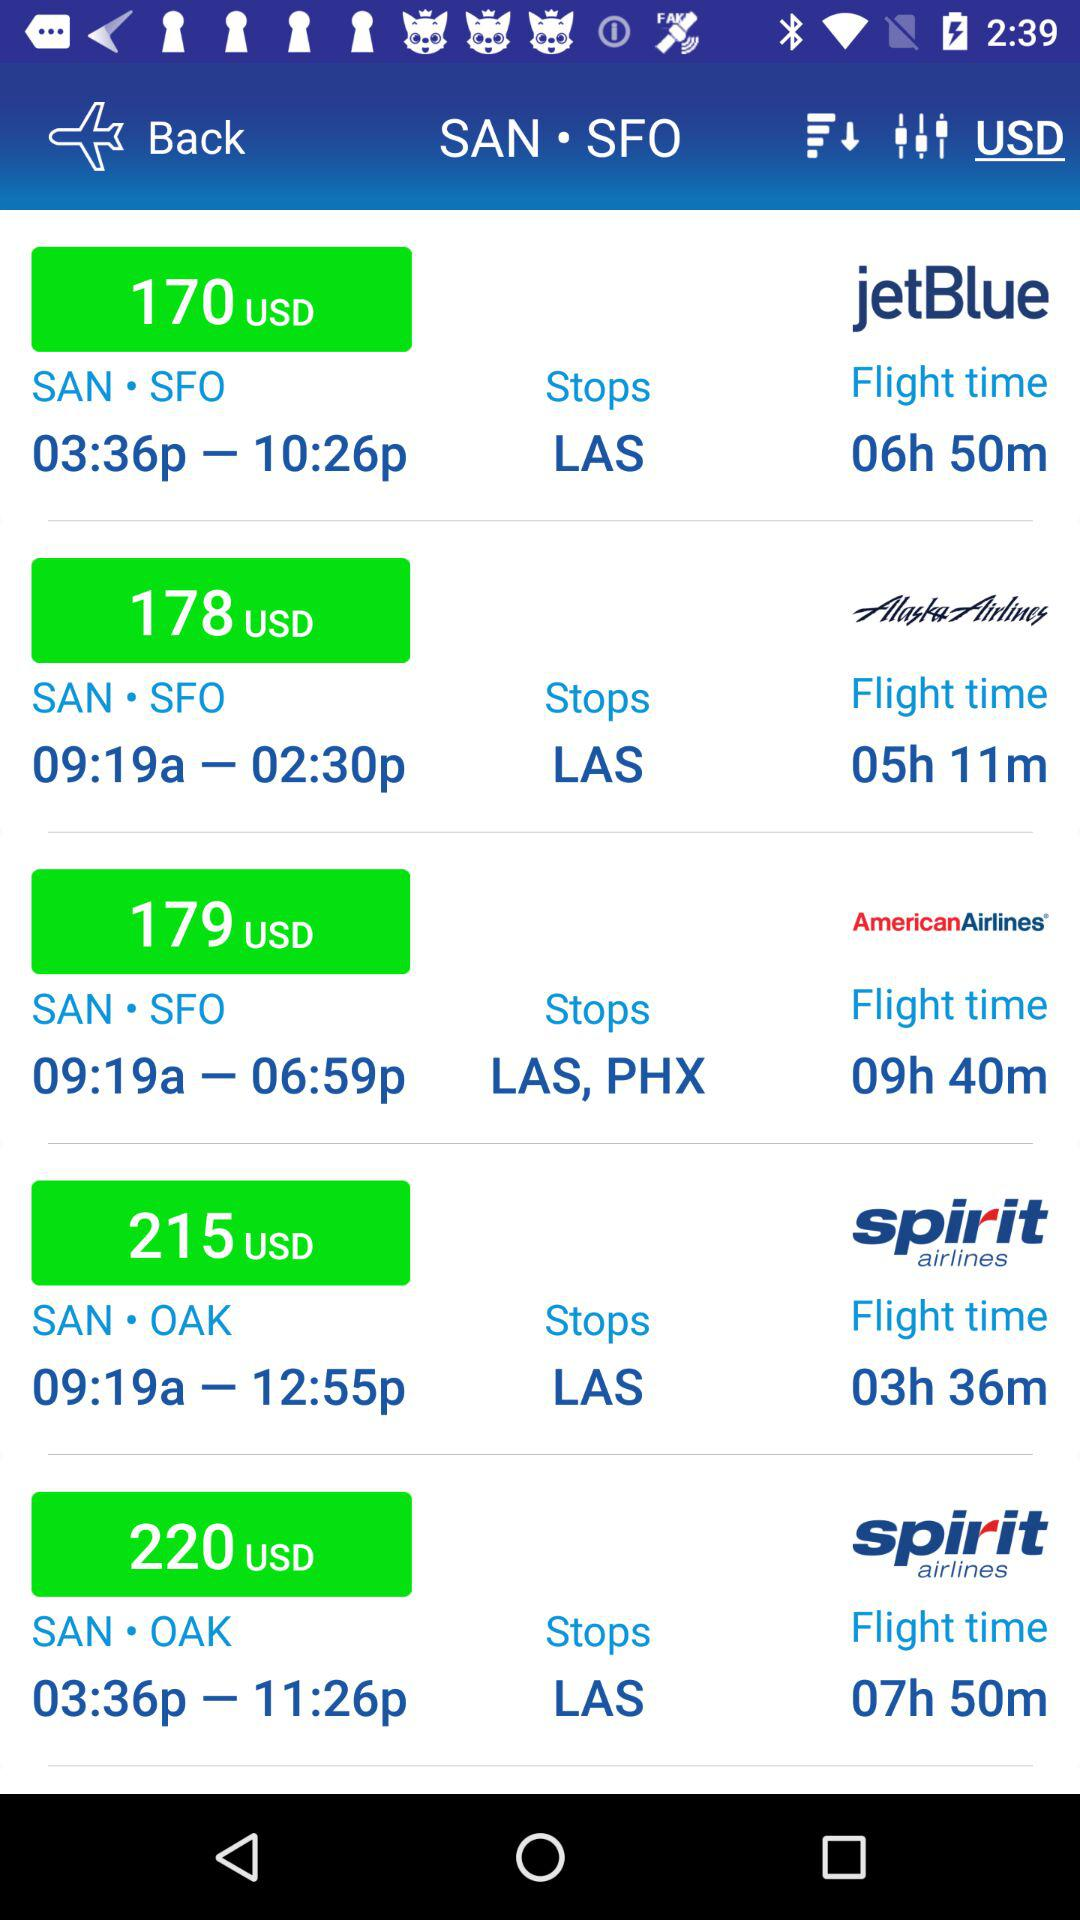What is the price of the ticket from SAN to SFO station on "jetBlue Airlines"? The price of the ticket from SAN to SFO station on "jetBlue Airlines" is 170 USD. 